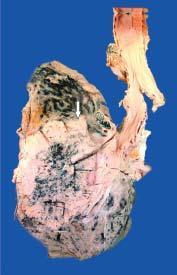what is seen extending directly into adjacent lung parenchyma and hilar nodes?
Answer the question using a single word or phrase. Tumour 